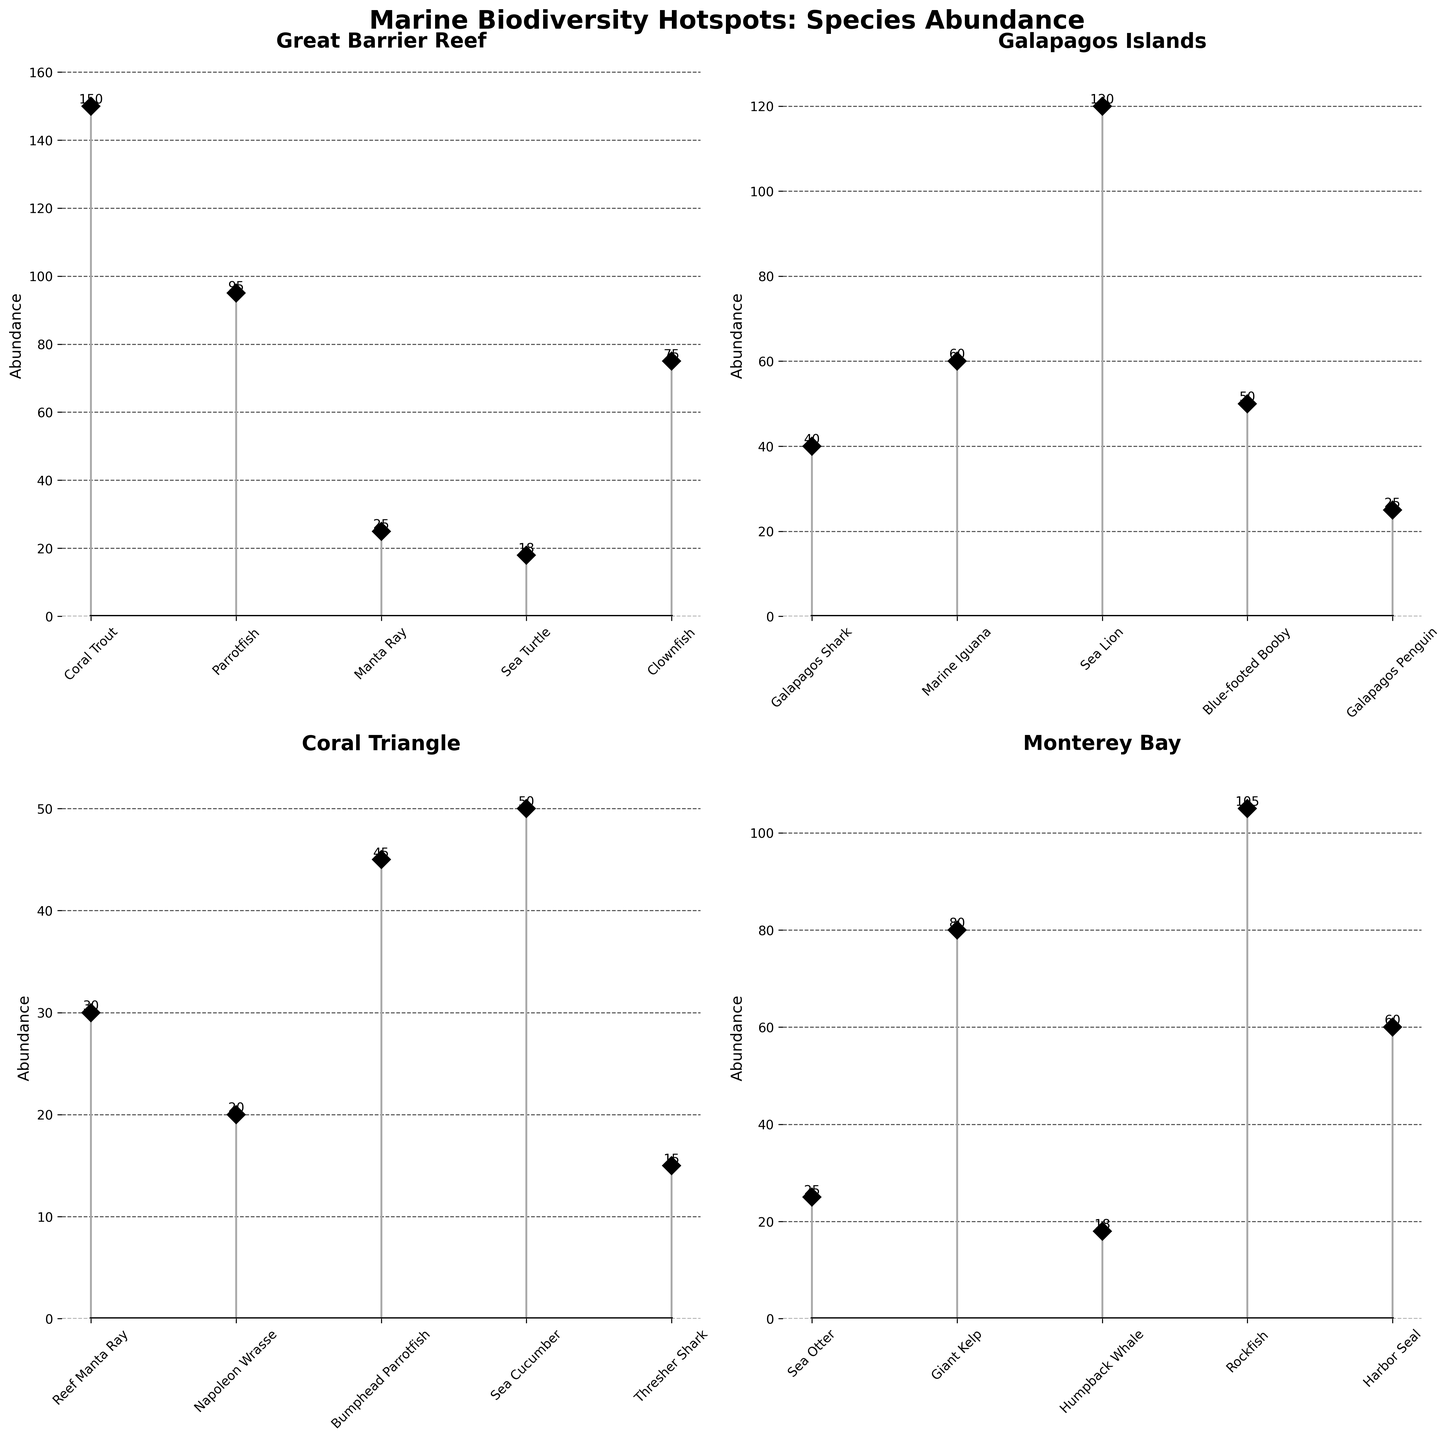What is the title of the figure? The title is displayed prominently at the top of the figure. It reads "Marine Biodiversity Hotspots: Species Abundance."
Answer: Marine Biodiversity Hotspots: Species Abundance How many species are displayed for the Great Barrier Reef? In the subplot for the Great Barrier Reef, you can count the number of markers along the x-axis, each representing a different species. There are 5 species: Coral Trout, Parrotfish, Manta Ray, Sea Turtle, and Clownfish.
Answer: 5 What is the species with the highest abundance in Monterey Bay? In the Monterey Bay subplot, the species with the highest marker and stem would indicate the highest abundance. The tallest stem corresponds to the Rockfish with an abundance of 105.
Answer: Rockfish What is the combined abundance of Galapagos Shark and Blue-footed Booby in the Galapagos Islands? In the Galapagos Islands subplot, the abundance of Galapagos Shark is 40 and the Blue-footed Booby is 50. Summing these values gives 40 + 50 = 90.
Answer: 90 Which location has the species with the lowest abundance, and what is that species? By comparing the minimum species abundances across all subplots, the lowest value is for the Thresher Shark in the Coral Triangle, with an abundance of 15.
Answer: Coral Triangle, Thresher Shark Which species has the closest abundance to 100 in any of the locations? In the Great Barrier Reef, Parrotfish has an abundance of 95, which is closest to 100 among all the species across the locations.
Answer: Parrotfish Are there any species common to multiple locations shown in the figure? Scanning through the species names in each subplot, there are no species names that appear in more than one subplot, implying no species are common between the given locations in this figure.
Answer: No What is the average abundance of species in the Coral Triangle? The abundances for species in the Coral Triangle are 30, 20, 45, 50, and 15. Summing these gives 30 + 20 + 45 + 50 + 15 = 160. There are 5 species, so the average is 160 / 5 = 32.
Answer: 32 